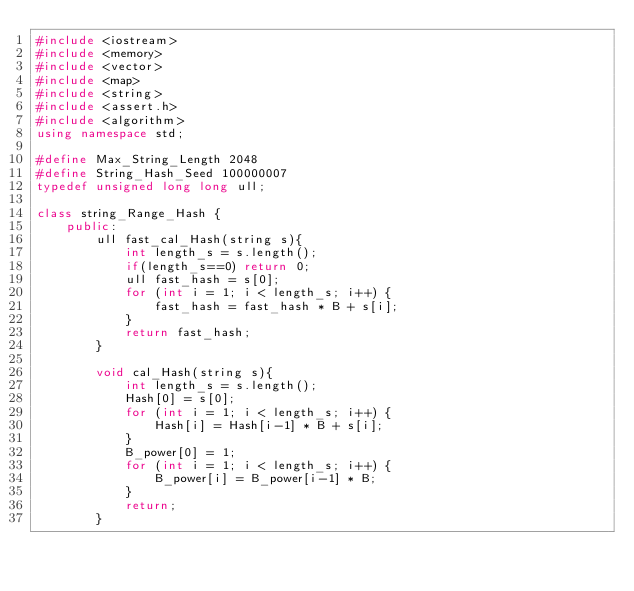Convert code to text. <code><loc_0><loc_0><loc_500><loc_500><_C++_>#include <iostream>
#include <memory>
#include <vector>
#include <map>
#include <string>
#include <assert.h>
#include <algorithm>
using namespace std;

#define Max_String_Length 2048
#define String_Hash_Seed 100000007
typedef unsigned long long ull;

class string_Range_Hash {
    public:
        ull fast_cal_Hash(string s){
            int length_s = s.length();
            if(length_s==0) return 0;
            ull fast_hash = s[0];
            for (int i = 1; i < length_s; i++) {
                fast_hash = fast_hash * B + s[i];
            }
            return fast_hash;
        }

        void cal_Hash(string s){
            int length_s = s.length();
            Hash[0] = s[0];
            for (int i = 1; i < length_s; i++) {
                Hash[i] = Hash[i-1] * B + s[i];
            }
            B_power[0] = 1;
            for (int i = 1; i < length_s; i++) {
                B_power[i] = B_power[i-1] * B;
            }
            return;
        }
</code> 